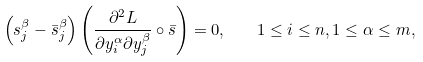Convert formula to latex. <formula><loc_0><loc_0><loc_500><loc_500>\left ( s _ { j } ^ { \beta } - \bar { s } _ { j } ^ { \beta } \right ) \left ( \frac { \partial ^ { 2 } L } { \partial y _ { i } ^ { \alpha } \partial y _ { j } ^ { \beta } } \circ \bar { s } \right ) = 0 , \quad 1 \leq i \leq n , 1 \leq \alpha \leq m ,</formula> 